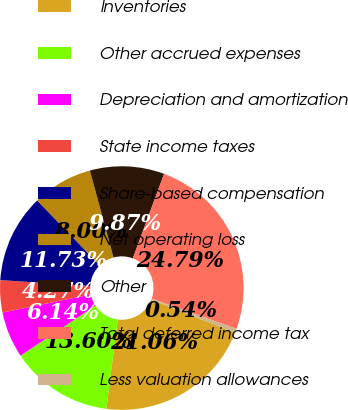<chart> <loc_0><loc_0><loc_500><loc_500><pie_chart><fcel>Inventories<fcel>Other accrued expenses<fcel>Depreciation and amortization<fcel>State income taxes<fcel>Share-based compensation<fcel>Net operating loss<fcel>Other<fcel>Total deferred income tax<fcel>Less valuation allowances<nl><fcel>21.06%<fcel>13.6%<fcel>6.14%<fcel>4.27%<fcel>11.73%<fcel>8.0%<fcel>9.87%<fcel>24.79%<fcel>0.54%<nl></chart> 